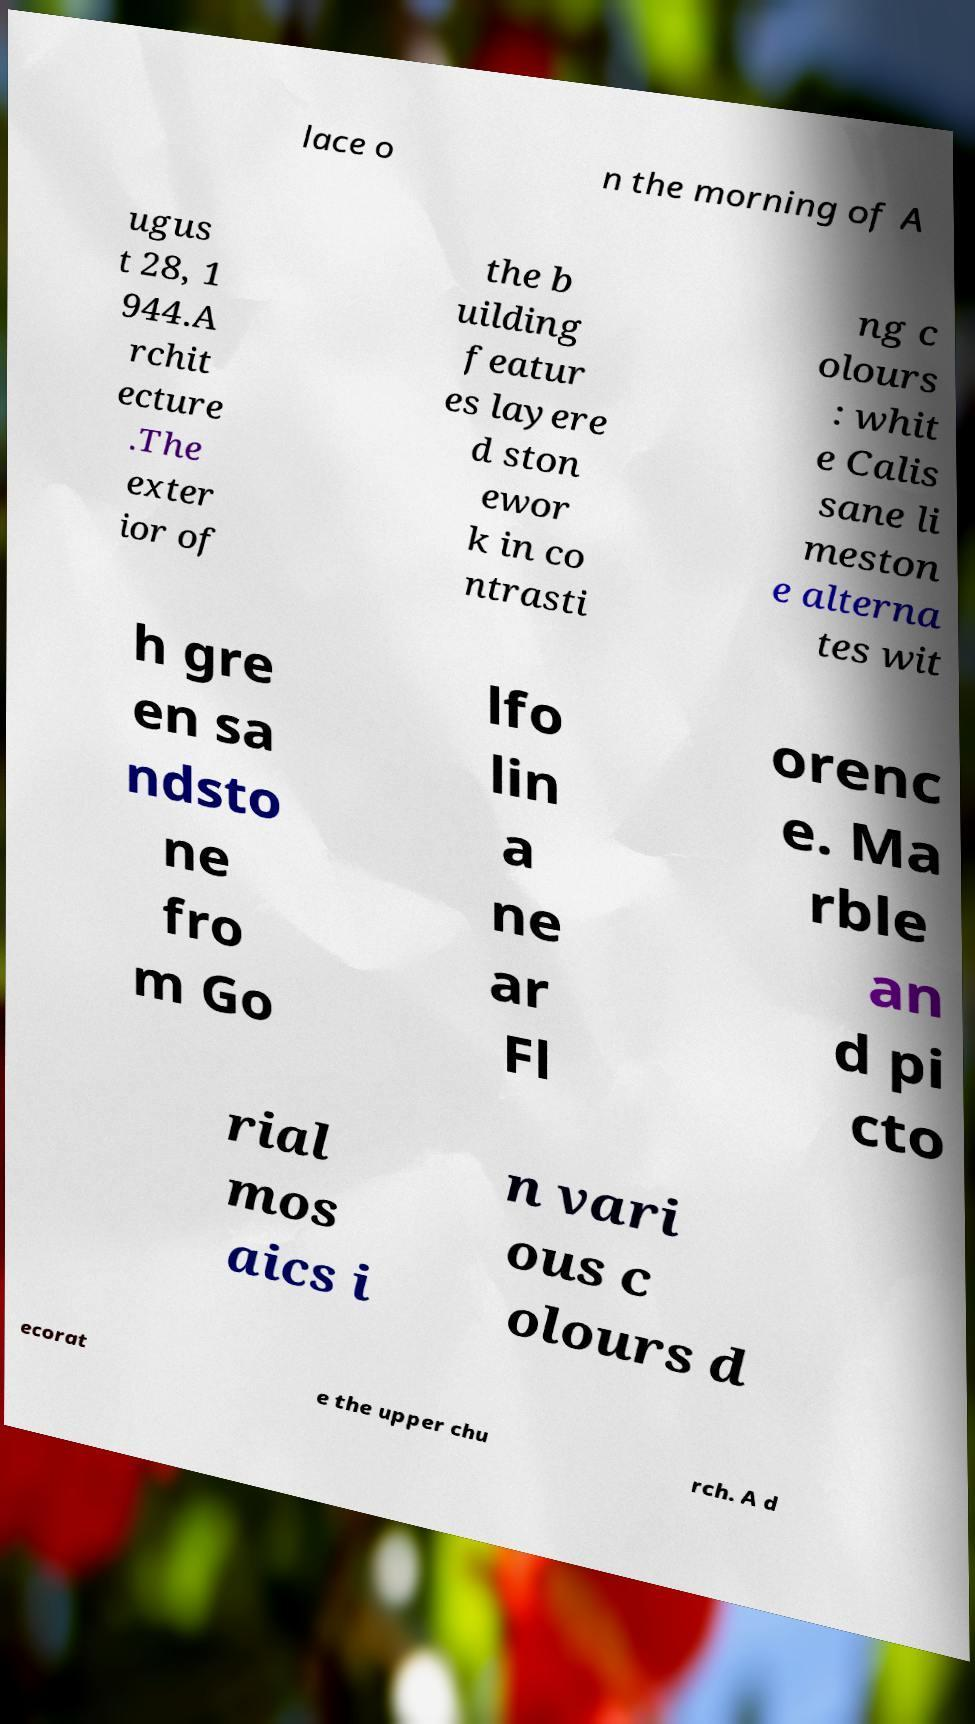Please identify and transcribe the text found in this image. lace o n the morning of A ugus t 28, 1 944.A rchit ecture .The exter ior of the b uilding featur es layere d ston ewor k in co ntrasti ng c olours : whit e Calis sane li meston e alterna tes wit h gre en sa ndsto ne fro m Go lfo lin a ne ar Fl orenc e. Ma rble an d pi cto rial mos aics i n vari ous c olours d ecorat e the upper chu rch. A d 